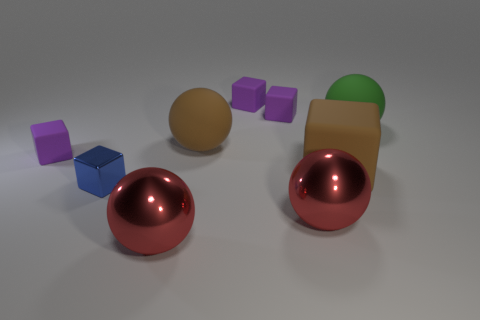Subtract all purple blocks. How many were subtracted if there are1purple blocks left? 2 Subtract all large matte cubes. How many cubes are left? 4 Subtract all purple blocks. How many red spheres are left? 2 Add 1 yellow rubber blocks. How many objects exist? 10 Subtract all brown blocks. How many blocks are left? 4 Add 2 large red objects. How many large red objects exist? 4 Subtract 0 yellow cylinders. How many objects are left? 9 Subtract all balls. How many objects are left? 5 Subtract all green balls. Subtract all blue cylinders. How many balls are left? 3 Subtract all green spheres. Subtract all large green rubber balls. How many objects are left? 7 